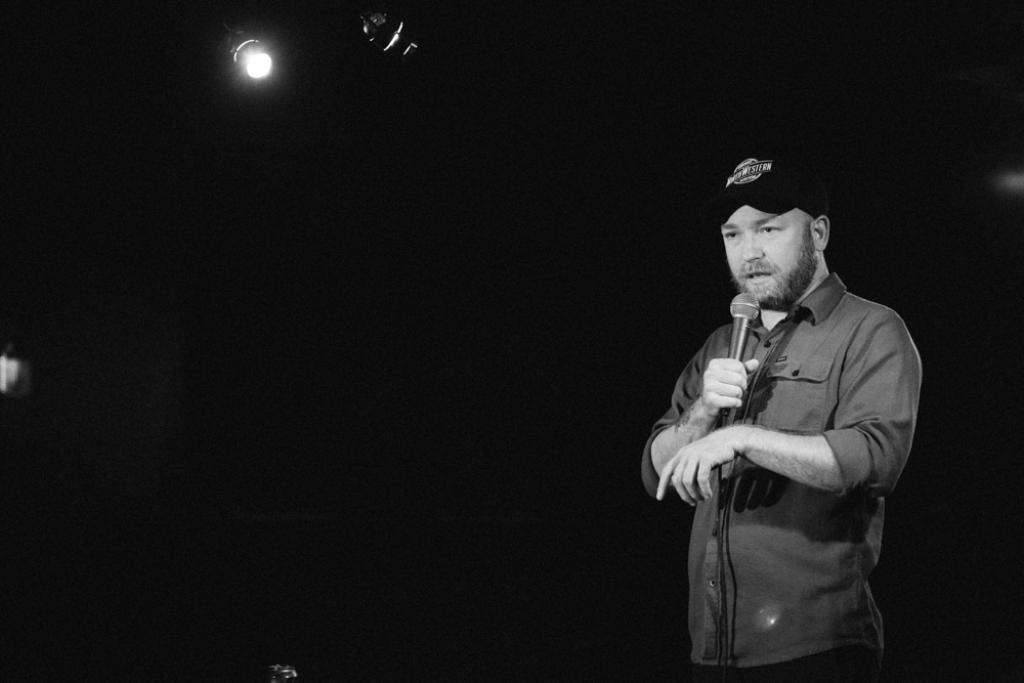In one or two sentences, can you explain what this image depicts? In this image I see a man who is wearing a cap and holding a mic, In the background I see the light. 